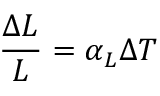Convert formula to latex. <formula><loc_0><loc_0><loc_500><loc_500>{ \frac { \Delta L } { L } } = \alpha _ { L } \Delta T</formula> 